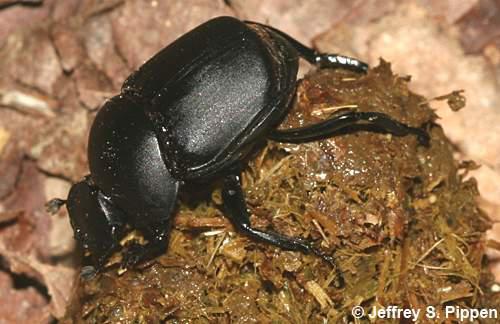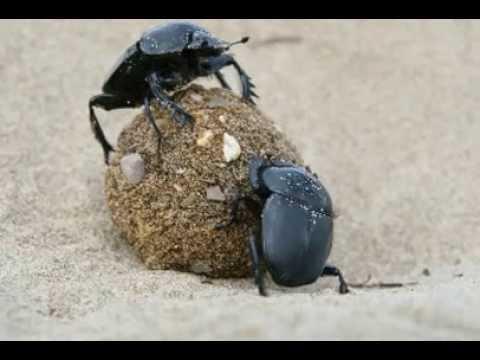The first image is the image on the left, the second image is the image on the right. Evaluate the accuracy of this statement regarding the images: "In each of the images only one dung beetle can be seen.". Is it true? Answer yes or no. No. 